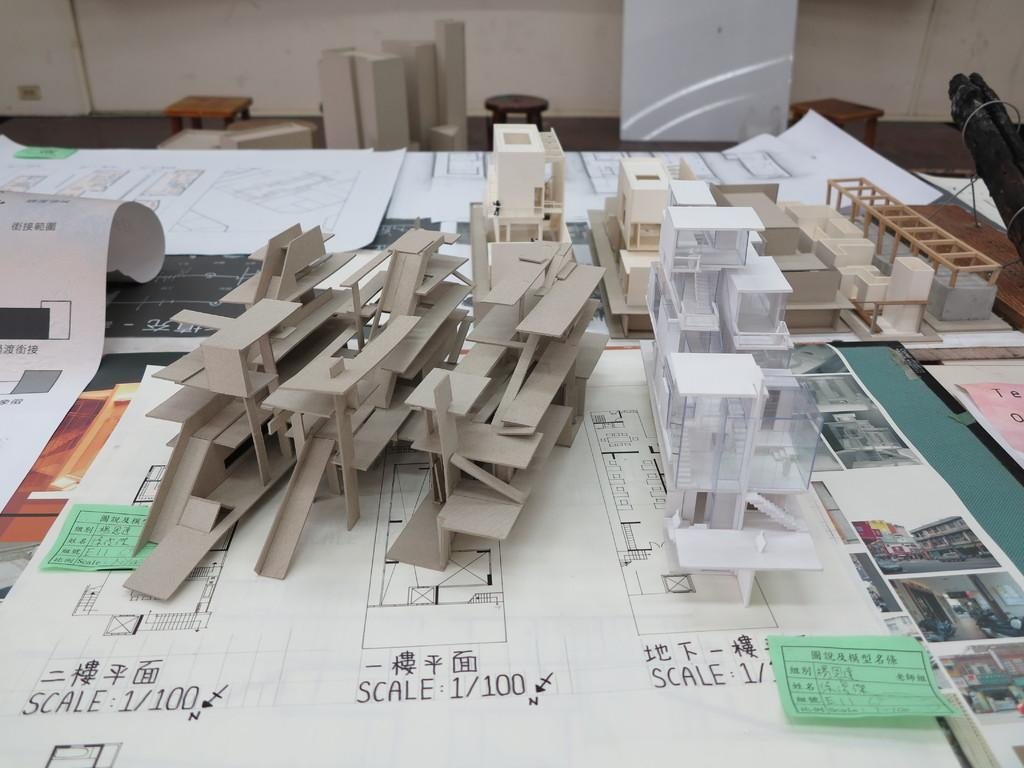<image>
Share a concise interpretation of the image provided. Plans and models sitting on plans that say the scale is 1/100. 